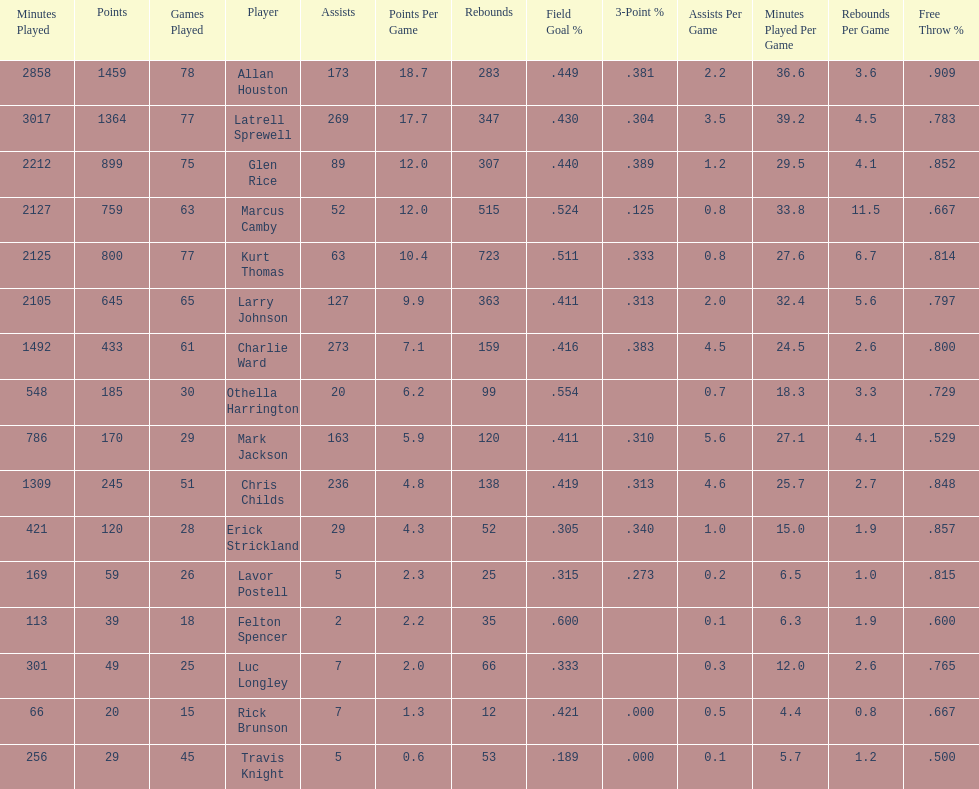How many more games did allan houston play than mark jackson? 49. 